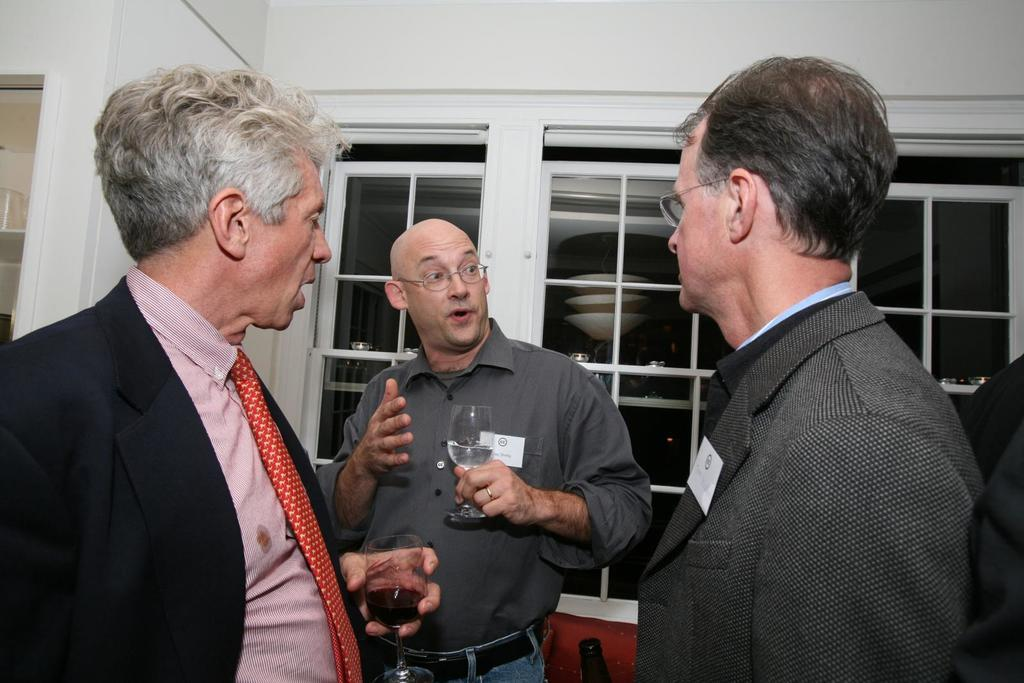What are the people in the image doing? The persons standing in the center of the image are holding glass tumblers. What can be seen in the background of the image? There are windows and a wall visible in the background. What type of balls are being played with in harmony in the image? There are no balls or any indication of harmony present in the image. 